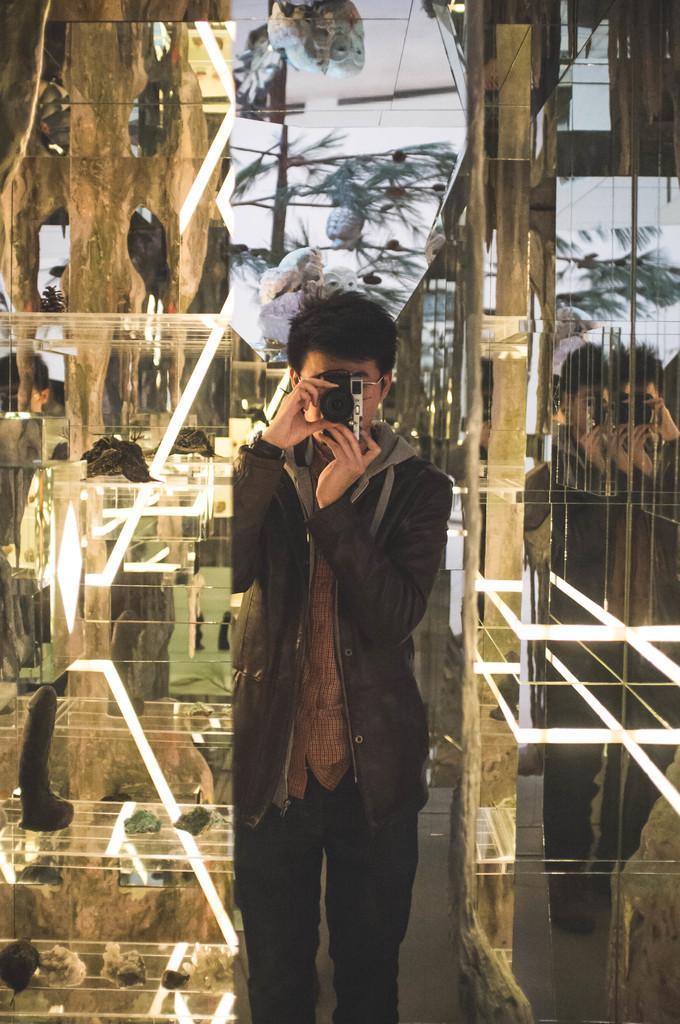How would you summarize this image in a sentence or two? In this picture in the middle, we can see a man standing and he is also holding camera in his two hands. In the background, we can see glass doors and some trees. 